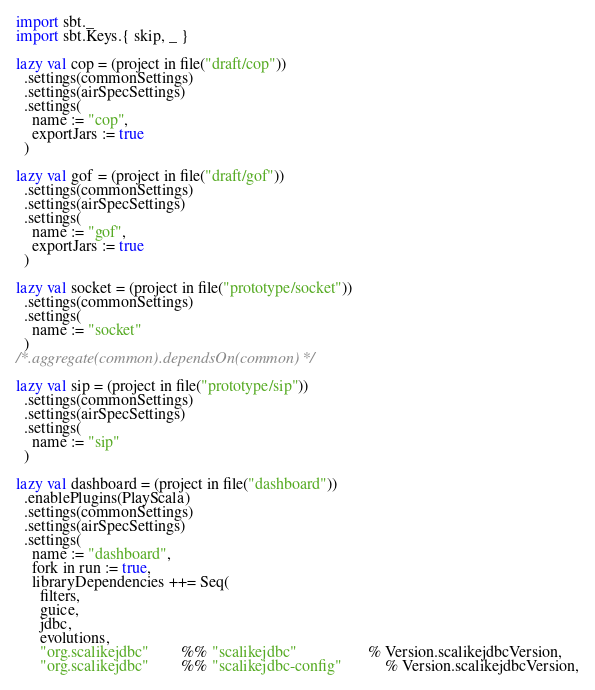Convert code to text. <code><loc_0><loc_0><loc_500><loc_500><_Scala_>import sbt._
import sbt.Keys.{ skip, _ }

lazy val cop = (project in file("draft/cop"))
  .settings(commonSettings)
  .settings(airSpecSettings)
  .settings(
    name := "cop",
    exportJars := true
  )

lazy val gof = (project in file("draft/gof"))
  .settings(commonSettings)
  .settings(airSpecSettings)
  .settings(
    name := "gof",
    exportJars := true
  )

lazy val socket = (project in file("prototype/socket"))
  .settings(commonSettings)
  .settings(
    name := "socket"
  )
/*.aggregate(common).dependsOn(common)*/

lazy val sip = (project in file("prototype/sip"))
  .settings(commonSettings)
  .settings(airSpecSettings)
  .settings(
    name := "sip"
  )

lazy val dashboard = (project in file("dashboard"))
  .enablePlugins(PlayScala)
  .settings(commonSettings)
  .settings(airSpecSettings)
  .settings(
    name := "dashboard",
    fork in run := true,
    libraryDependencies ++= Seq(
      filters,
      guice,
      jdbc,
      evolutions,
      "org.scalikejdbc"        %% "scalikejdbc"                  % Version.scalikejdbcVersion,
      "org.scalikejdbc"        %% "scalikejdbc-config"           % Version.scalikejdbcVersion,</code> 